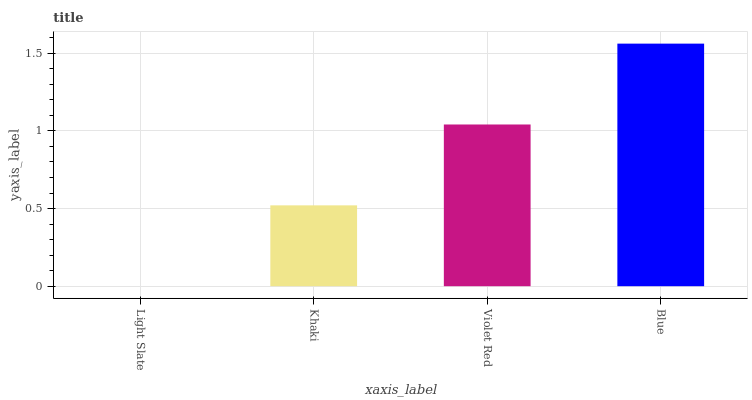Is Light Slate the minimum?
Answer yes or no. Yes. Is Blue the maximum?
Answer yes or no. Yes. Is Khaki the minimum?
Answer yes or no. No. Is Khaki the maximum?
Answer yes or no. No. Is Khaki greater than Light Slate?
Answer yes or no. Yes. Is Light Slate less than Khaki?
Answer yes or no. Yes. Is Light Slate greater than Khaki?
Answer yes or no. No. Is Khaki less than Light Slate?
Answer yes or no. No. Is Violet Red the high median?
Answer yes or no. Yes. Is Khaki the low median?
Answer yes or no. Yes. Is Light Slate the high median?
Answer yes or no. No. Is Light Slate the low median?
Answer yes or no. No. 